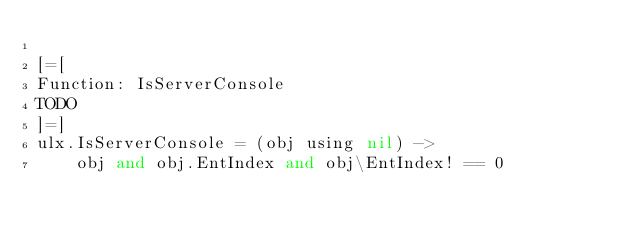<code> <loc_0><loc_0><loc_500><loc_500><_MoonScript_>
[=[
Function: IsServerConsole
TODO
]=]
ulx.IsServerConsole = (obj using nil) ->
	obj and obj.EntIndex and obj\EntIndex! == 0
</code> 